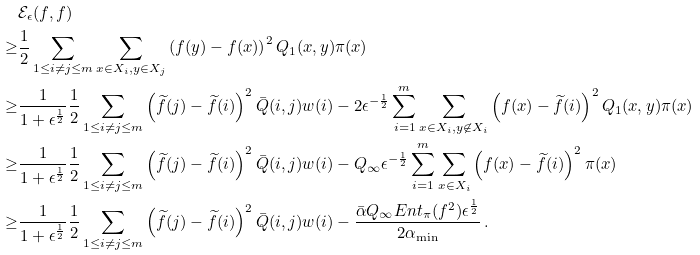Convert formula to latex. <formula><loc_0><loc_0><loc_500><loc_500>& \mathcal { E } _ { \epsilon } ( f , f ) \\ \geq & \frac { 1 } { 2 } \sum _ { 1 \leq i \neq j \leq m } \sum _ { x \in X _ { i } , y \in X _ { j } } \left ( f ( y ) - f ( x ) \right ) ^ { 2 } Q _ { 1 } ( x , y ) \pi ( x ) \\ \geq & \frac { 1 } { 1 + \epsilon ^ { \frac { 1 } { 2 } } } \frac { 1 } { 2 } \sum _ { 1 \leq i \neq j \leq m } \left ( \widetilde { f } ( j ) - \widetilde { f } ( i ) \right ) ^ { 2 } \bar { Q } ( i , j ) w ( i ) - 2 \epsilon ^ { - \frac { 1 } { 2 } } \sum _ { i = 1 } ^ { m } \sum _ { x \in X _ { i } , y \not \in X _ { i } } \left ( f ( x ) - \widetilde { f } ( i ) \right ) ^ { 2 } Q _ { 1 } ( x , y ) \pi ( x ) \\ \geq & \frac { 1 } { 1 + \epsilon ^ { \frac { 1 } { 2 } } } \frac { 1 } { 2 } \sum _ { 1 \leq i \neq j \leq m } \left ( \widetilde { f } ( j ) - \widetilde { f } ( i ) \right ) ^ { 2 } \bar { Q } ( i , j ) w ( i ) - Q _ { \infty } \epsilon ^ { - \frac { 1 } { 2 } } \sum _ { i = 1 } ^ { m } \sum _ { x \in X _ { i } } \left ( f ( x ) - \widetilde { f } ( i ) \right ) ^ { 2 } \pi ( x ) \\ \geq & \frac { 1 } { 1 + \epsilon ^ { \frac { 1 } { 2 } } } \frac { 1 } { 2 } \sum _ { 1 \leq i \neq j \leq m } \left ( \widetilde { f } ( j ) - \widetilde { f } ( i ) \right ) ^ { 2 } \bar { Q } ( i , j ) w ( i ) - \frac { \bar { \alpha } Q _ { \infty } E n t _ { \pi } ( f ^ { 2 } ) \epsilon ^ { \frac { 1 } { 2 } } } { 2 \alpha _ { \min } } \, .</formula> 